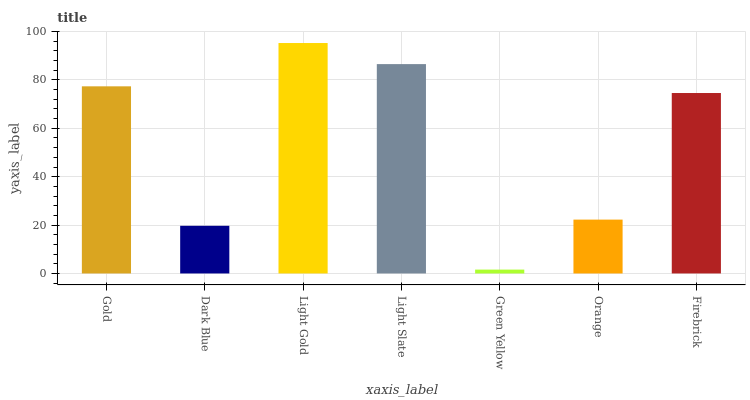Is Dark Blue the minimum?
Answer yes or no. No. Is Dark Blue the maximum?
Answer yes or no. No. Is Gold greater than Dark Blue?
Answer yes or no. Yes. Is Dark Blue less than Gold?
Answer yes or no. Yes. Is Dark Blue greater than Gold?
Answer yes or no. No. Is Gold less than Dark Blue?
Answer yes or no. No. Is Firebrick the high median?
Answer yes or no. Yes. Is Firebrick the low median?
Answer yes or no. Yes. Is Green Yellow the high median?
Answer yes or no. No. Is Light Slate the low median?
Answer yes or no. No. 